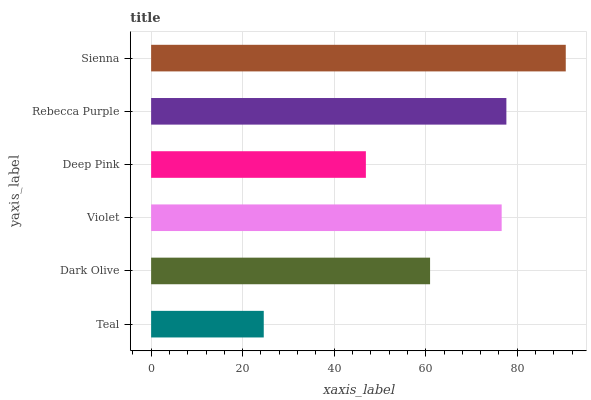Is Teal the minimum?
Answer yes or no. Yes. Is Sienna the maximum?
Answer yes or no. Yes. Is Dark Olive the minimum?
Answer yes or no. No. Is Dark Olive the maximum?
Answer yes or no. No. Is Dark Olive greater than Teal?
Answer yes or no. Yes. Is Teal less than Dark Olive?
Answer yes or no. Yes. Is Teal greater than Dark Olive?
Answer yes or no. No. Is Dark Olive less than Teal?
Answer yes or no. No. Is Violet the high median?
Answer yes or no. Yes. Is Dark Olive the low median?
Answer yes or no. Yes. Is Dark Olive the high median?
Answer yes or no. No. Is Teal the low median?
Answer yes or no. No. 